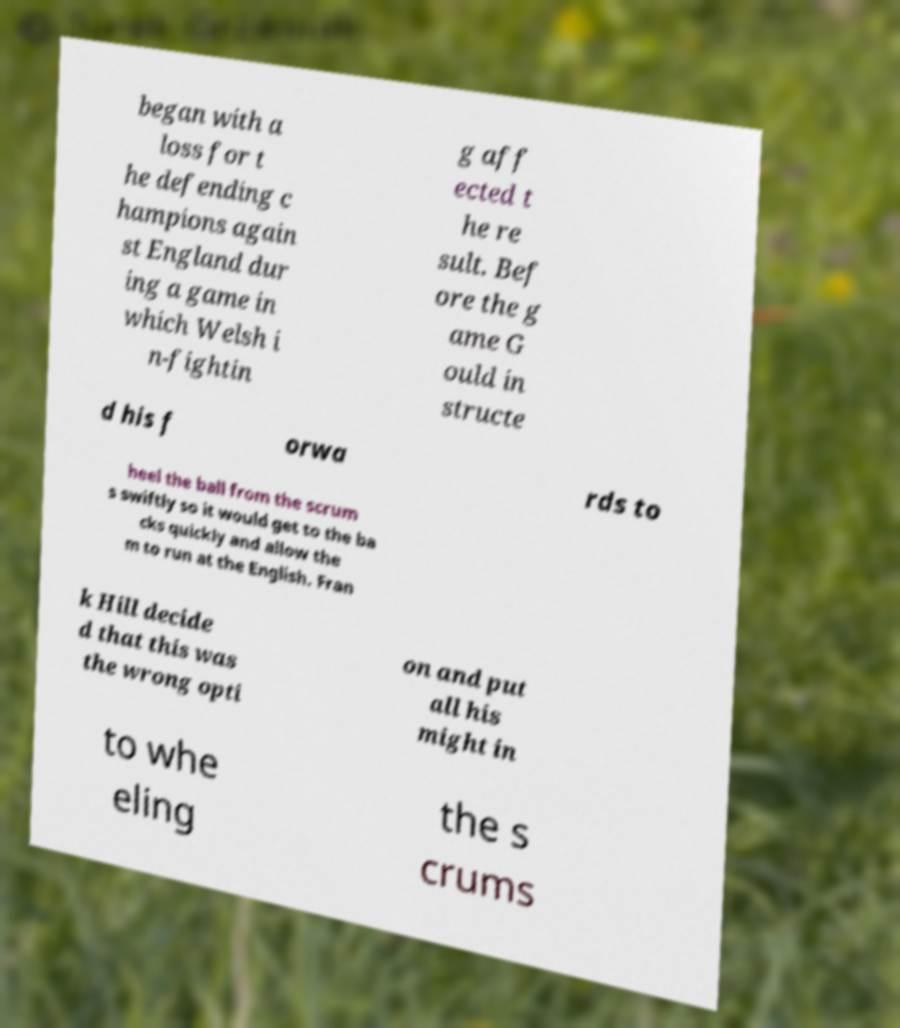There's text embedded in this image that I need extracted. Can you transcribe it verbatim? began with a loss for t he defending c hampions again st England dur ing a game in which Welsh i n-fightin g aff ected t he re sult. Bef ore the g ame G ould in structe d his f orwa rds to heel the ball from the scrum s swiftly so it would get to the ba cks quickly and allow the m to run at the English. Fran k Hill decide d that this was the wrong opti on and put all his might in to whe eling the s crums 